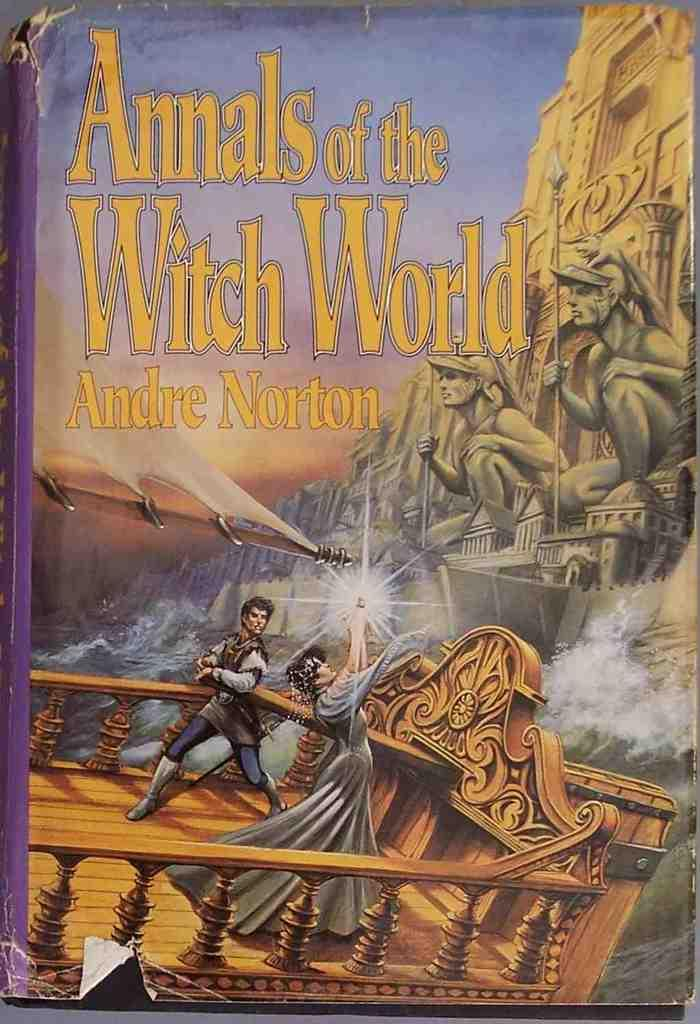What object is present in the image? There is a book in the image. What is depicted on the cover page of the book? The cover page of the book contains two persons, a building, and water. What type of van can be seen parked near the hill in the image? There is no van or hill present in the image; the cover page of the book contains only the two persons, the building, and the water. 